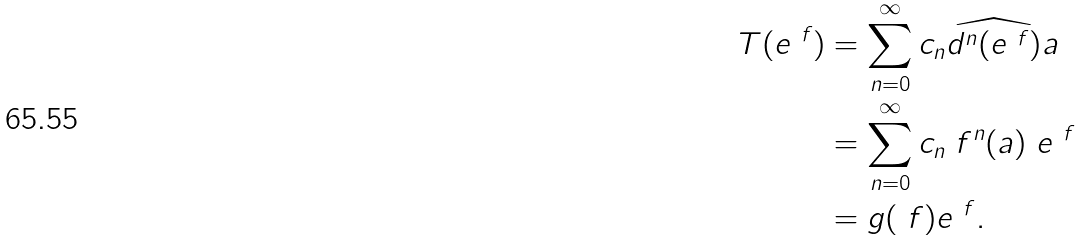Convert formula to latex. <formula><loc_0><loc_0><loc_500><loc_500>T ( e ^ { \ f } ) & = \sum _ { n = 0 } ^ { \infty } c _ { n } \widehat { d ^ { n } ( e ^ { \ f } ) } a \\ & = \sum _ { n = 0 } ^ { \infty } c _ { n } \ f ^ { n } ( a ) \ e ^ { \ f } \\ & = g ( \ f ) e ^ { \ f } .</formula> 